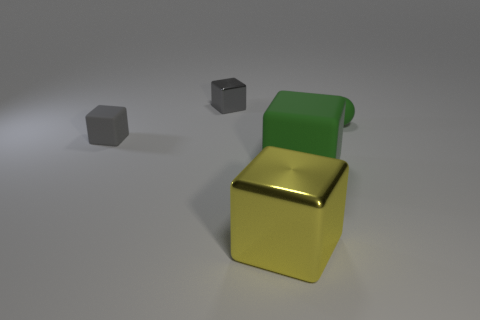What materials are the objects in this image made of? The objects appear to be rendered with different materials. The small cube and sphere have a matte finish, suggesting a solid, non-reflective surface, while the large cube has a glossy, metallic finish, indicating a reflective material like polished metal. 